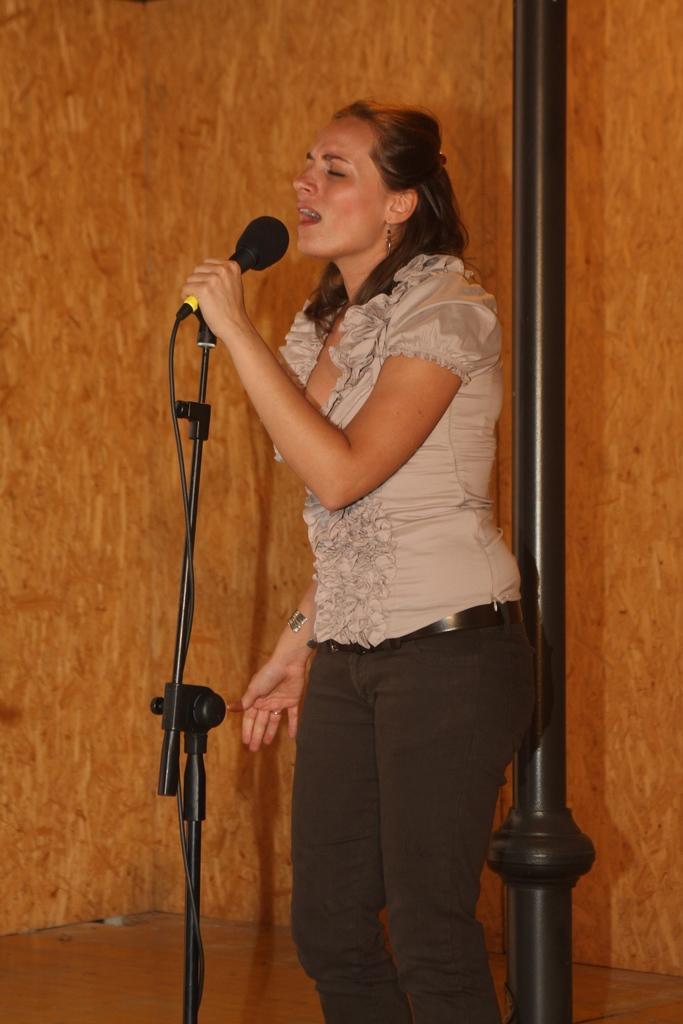Can you describe this image briefly? In this picture a lady is singing with a black mic in her hand. In the background we observe a beautifully decorated brown background. 